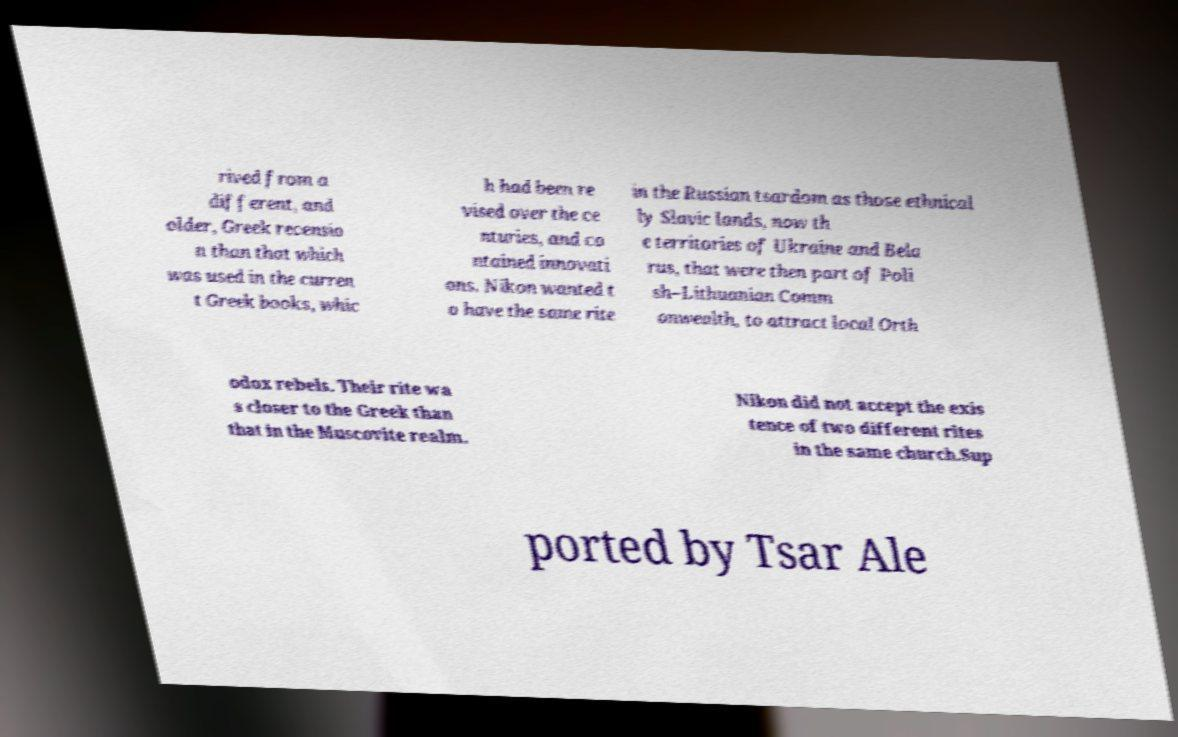Can you accurately transcribe the text from the provided image for me? rived from a different, and older, Greek recensio n than that which was used in the curren t Greek books, whic h had been re vised over the ce nturies, and co ntained innovati ons. Nikon wanted t o have the same rite in the Russian tsardom as those ethnical ly Slavic lands, now th e territories of Ukraine and Bela rus, that were then part of Poli sh–Lithuanian Comm onwealth, to attract local Orth odox rebels. Their rite wa s closer to the Greek than that in the Muscovite realm. Nikon did not accept the exis tence of two different rites in the same church.Sup ported by Tsar Ale 